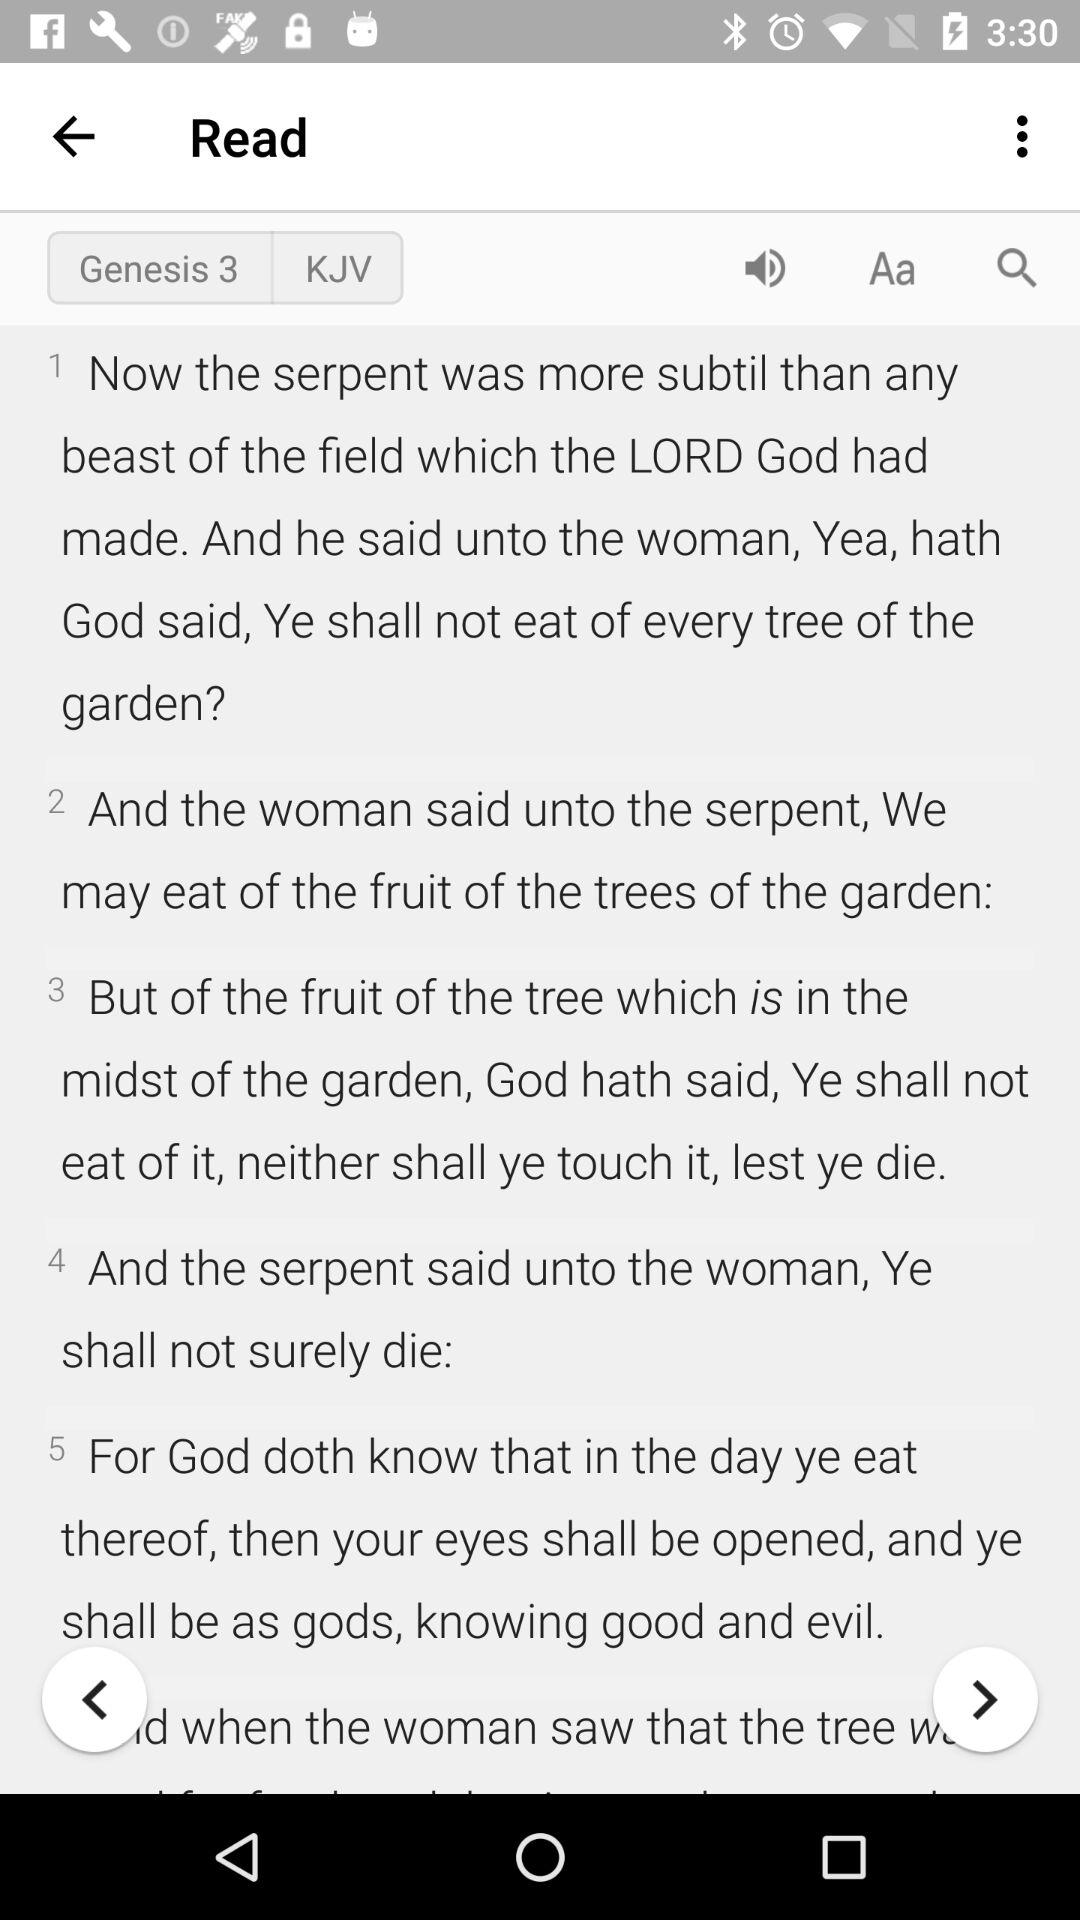How many verses are there in this passage?
Answer the question using a single word or phrase. 5 